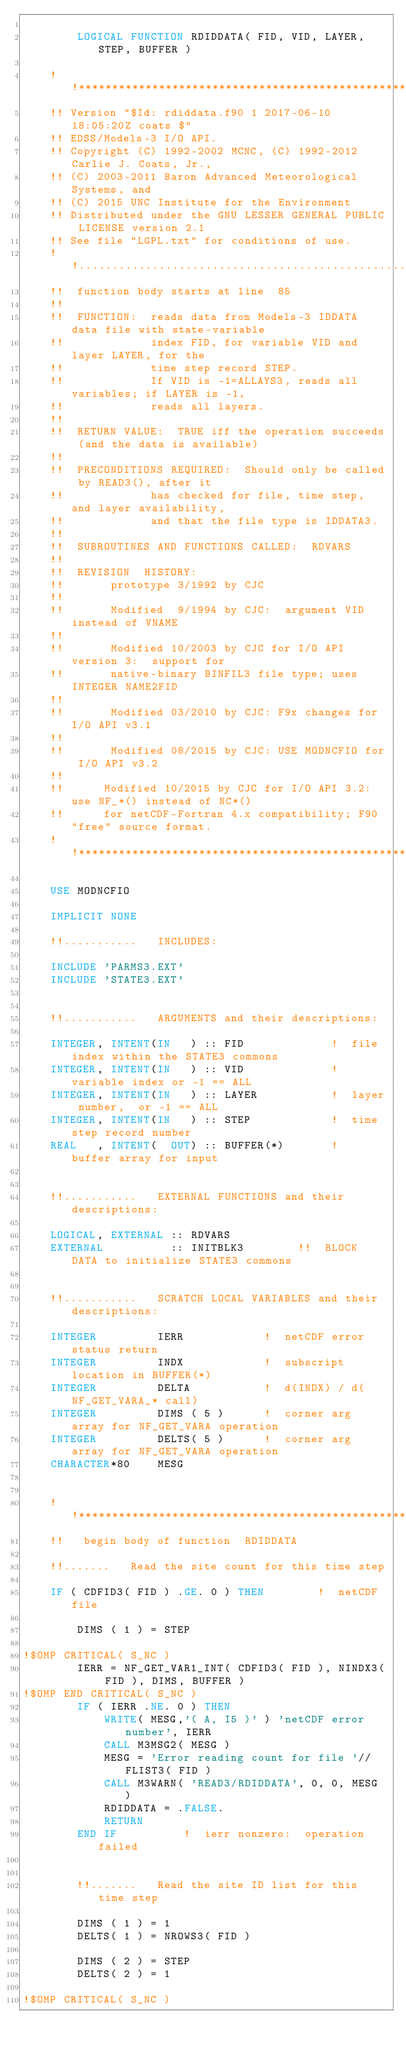<code> <loc_0><loc_0><loc_500><loc_500><_FORTRAN_>
        LOGICAL FUNCTION RDIDDATA( FID, VID, LAYER, STEP, BUFFER )

    !!***********************************************************************
    !! Version "$Id: rdiddata.f90 1 2017-06-10 18:05:20Z coats $"
    !! EDSS/Models-3 I/O API.
    !! Copyright (C) 1992-2002 MCNC, (C) 1992-2012 Carlie J. Coats, Jr.,
    !! (C) 2003-2011 Baron Advanced Meteorological Systems, and
    !! (C) 2015 UNC Institute for the Environment
    !! Distributed under the GNU LESSER GENERAL PUBLIC LICENSE version 2.1
    !! See file "LGPL.txt" for conditions of use.
    !!.........................................................................
    !!  function body starts at line  85
    !!
    !!  FUNCTION:  reads data from Models-3 IDDATA data file with state-variable
    !!             index FID, for variable VID and layer LAYER, for the
    !!             time step record STEP.
    !!             If VID is -1=ALLAYS3, reads all variables; if LAYER is -1,
    !!             reads all layers.
    !!
    !!  RETURN VALUE:  TRUE iff the operation succeeds (and the data is available)
    !!
    !!  PRECONDITIONS REQUIRED:  Should only be called by READ3(), after it
    !!             has checked for file, time step, and layer availability,
    !!             and that the file type is IDDATA3.
    !!
    !!  SUBROUTINES AND FUNCTIONS CALLED:  RDVARS
    !!
    !!  REVISION  HISTORY:
    !!       prototype 3/1992 by CJC
    !!
    !!       Modified  9/1994 by CJC:  argument VID instead of VNAME
    !!
    !!       Modified 10/2003 by CJC for I/O API version 3:  support for
    !!       native-binary BINFIL3 file type; uses INTEGER NAME2FID
    !!
    !!       Modified 03/2010 by CJC: F9x changes for I/O API v3.1
    !!
    !!       Modified 08/2015 by CJC: USE MODNCFIO for I/O API v3.2
    !!
    !!      Modified 10/2015 by CJC for I/O API 3.2: use NF_*() instead of NC*()
    !!      for netCDF-Fortran 4.x compatibility; F90 "free" source format.
    !!***********************************************************************

    USE MODNCFIO

    IMPLICIT NONE

    !!...........   INCLUDES:

    INCLUDE 'PARMS3.EXT'
    INCLUDE 'STATE3.EXT'


    !!...........   ARGUMENTS and their descriptions:

    INTEGER, INTENT(IN   ) :: FID             !  file index within the STATE3 commons
    INTEGER, INTENT(IN   ) :: VID             !  variable index or -1 == ALL
    INTEGER, INTENT(IN   ) :: LAYER           !  layer number,  or -1 == ALL
    INTEGER, INTENT(IN   ) :: STEP            !  time step record number
    REAL   , INTENT(  OUT) :: BUFFER(*)       !  buffer array for input


    !!...........   EXTERNAL FUNCTIONS and their descriptions:

    LOGICAL, EXTERNAL :: RDVARS
    EXTERNAL          :: INITBLK3        !!  BLOCK DATA to initialize STATE3 commons


    !!...........   SCRATCH LOCAL VARIABLES and their descriptions:

    INTEGER         IERR            !  netCDF error status return
    INTEGER         INDX            !  subscript location in BUFFER(*)
    INTEGER         DELTA           !  d(INDX) / d(NF_GET_VARA_* call)
    INTEGER         DIMS ( 5 )      !  corner arg array for NF_GET_VARA operation
    INTEGER         DELTS( 5 )      !  corner arg array for NF_GET_VARA operation
    CHARACTER*80    MESG


    !!***********************************************************************
    !!   begin body of function  RDIDDATA

    !!.......   Read the site count for this time step

    IF ( CDFID3( FID ) .GE. 0 ) THEN        !  netCDF file

        DIMS ( 1 ) = STEP

!$OMP CRITICAL( S_NC )
        IERR = NF_GET_VAR1_INT( CDFID3( FID ), NINDX3( FID ), DIMS, BUFFER )
!$OMP END CRITICAL( S_NC )
        IF ( IERR .NE. 0 ) THEN
            WRITE( MESG,'( A, I5 )' ) 'netCDF error number', IERR
            CALL M3MSG2( MESG )
            MESG = 'Error reading count for file '//FLIST3( FID )
            CALL M3WARN( 'READ3/RDIDDATA', 0, 0, MESG )
            RDIDDATA = .FALSE.
            RETURN
        END IF          !  ierr nonzero:  operation failed


        !!.......   Read the site ID list for this time step

        DIMS ( 1 ) = 1
        DELTS( 1 ) = NROWS3( FID )

        DIMS ( 2 ) = STEP
        DELTS( 2 ) = 1

!$OMP CRITICAL( S_NC )</code> 